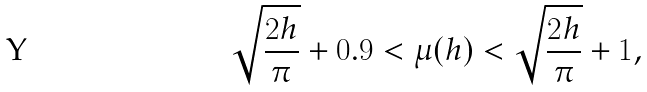<formula> <loc_0><loc_0><loc_500><loc_500>\sqrt { \frac { 2 h } { \pi } } + 0 . 9 < \mu ( h ) < \sqrt { \frac { 2 h } { \pi } } + 1 ,</formula> 